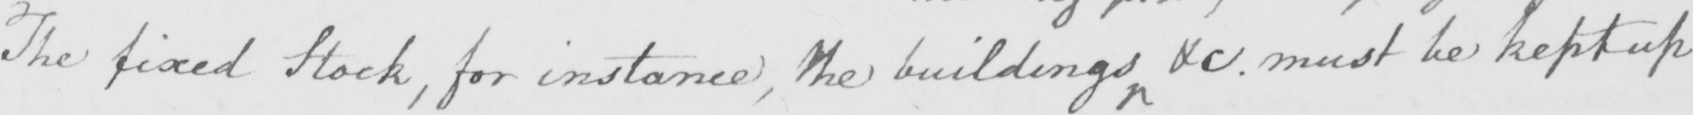What text is written in this handwritten line? The fixed Stock , for instance , the building &c . must be kept up 